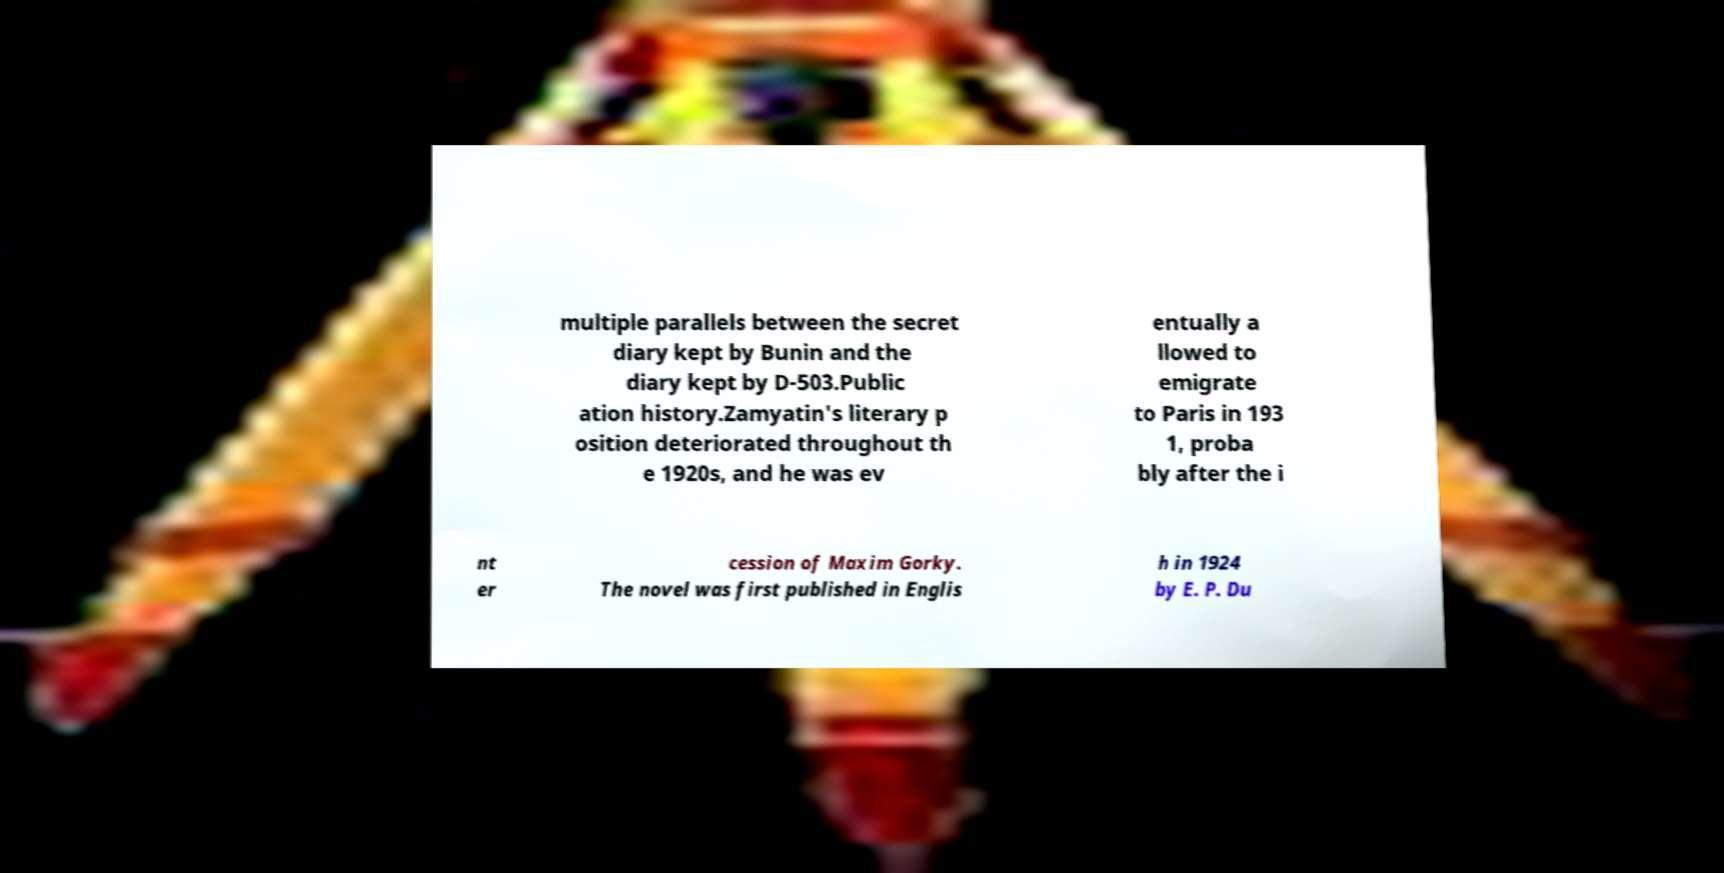What messages or text are displayed in this image? I need them in a readable, typed format. multiple parallels between the secret diary kept by Bunin and the diary kept by D-503.Public ation history.Zamyatin's literary p osition deteriorated throughout th e 1920s, and he was ev entually a llowed to emigrate to Paris in 193 1, proba bly after the i nt er cession of Maxim Gorky. The novel was first published in Englis h in 1924 by E. P. Du 